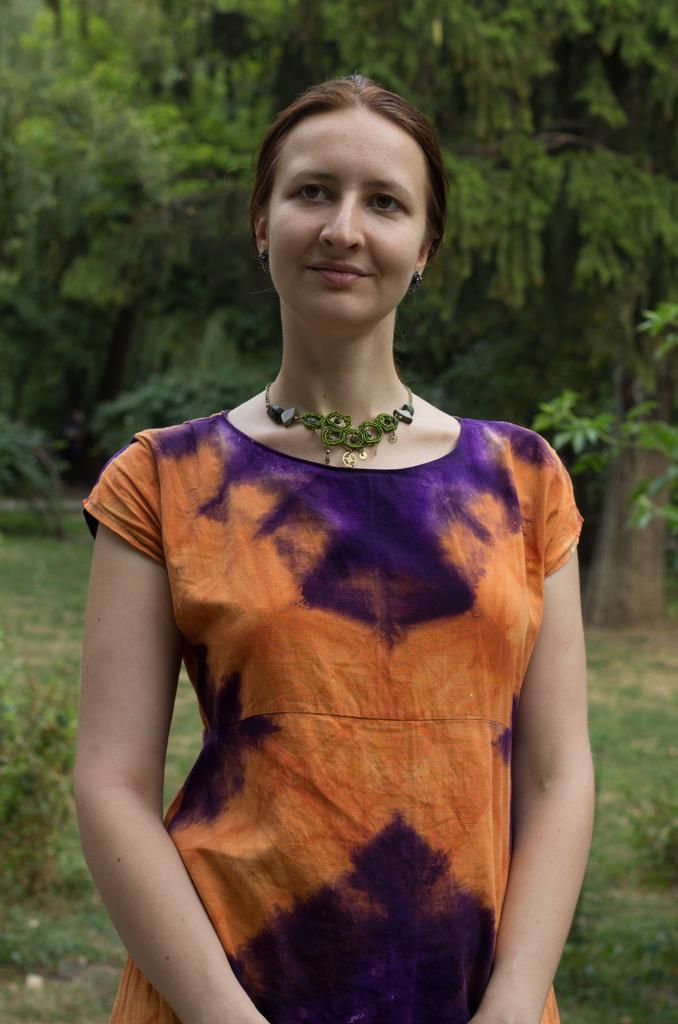Who is the main subject in the image? There is a lady in the center of the image. What is the lady doing in the image? The lady is standing and smiling. What can be seen in the background of the image? There are trees in the background of the image. What type of ground is visible at the bottom of the image? There is grass at the bottom of the image. What type of eggnog is the lady holding in the image? There is no eggnog present in the image; the lady is not holding any drink or object. 